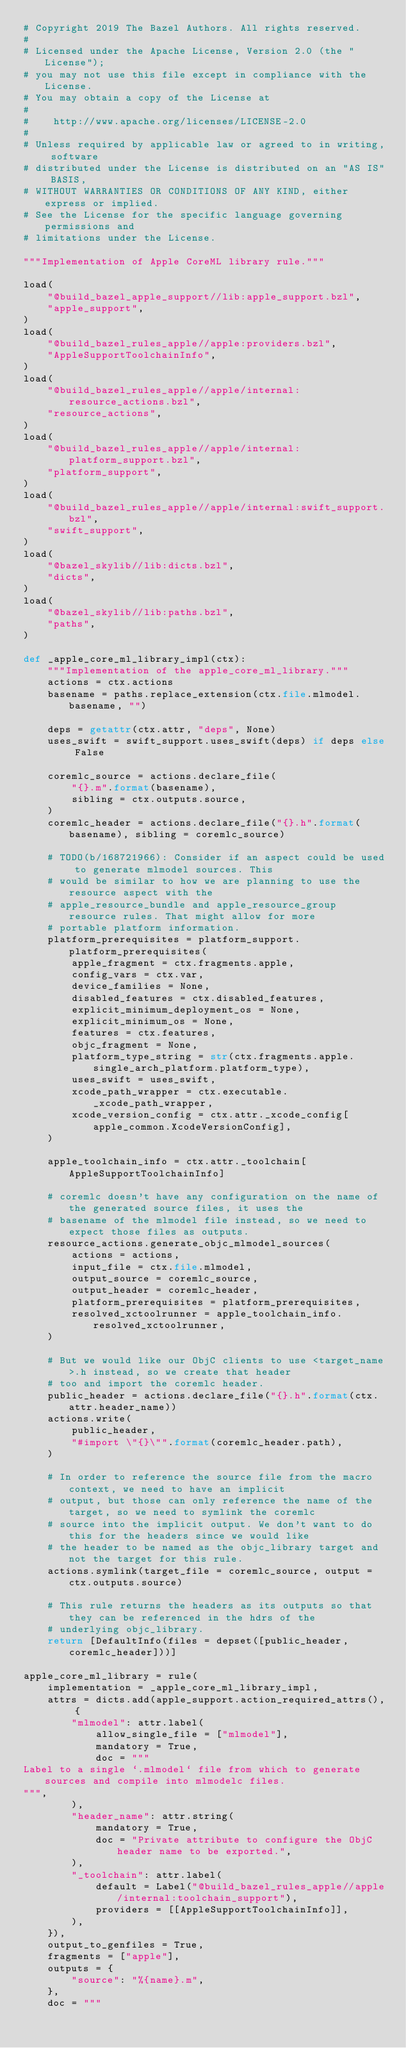Convert code to text. <code><loc_0><loc_0><loc_500><loc_500><_Python_># Copyright 2019 The Bazel Authors. All rights reserved.
#
# Licensed under the Apache License, Version 2.0 (the "License");
# you may not use this file except in compliance with the License.
# You may obtain a copy of the License at
#
#    http://www.apache.org/licenses/LICENSE-2.0
#
# Unless required by applicable law or agreed to in writing, software
# distributed under the License is distributed on an "AS IS" BASIS,
# WITHOUT WARRANTIES OR CONDITIONS OF ANY KIND, either express or implied.
# See the License for the specific language governing permissions and
# limitations under the License.

"""Implementation of Apple CoreML library rule."""

load(
    "@build_bazel_apple_support//lib:apple_support.bzl",
    "apple_support",
)
load(
    "@build_bazel_rules_apple//apple:providers.bzl",
    "AppleSupportToolchainInfo",
)
load(
    "@build_bazel_rules_apple//apple/internal:resource_actions.bzl",
    "resource_actions",
)
load(
    "@build_bazel_rules_apple//apple/internal:platform_support.bzl",
    "platform_support",
)
load(
    "@build_bazel_rules_apple//apple/internal:swift_support.bzl",
    "swift_support",
)
load(
    "@bazel_skylib//lib:dicts.bzl",
    "dicts",
)
load(
    "@bazel_skylib//lib:paths.bzl",
    "paths",
)

def _apple_core_ml_library_impl(ctx):
    """Implementation of the apple_core_ml_library."""
    actions = ctx.actions
    basename = paths.replace_extension(ctx.file.mlmodel.basename, "")

    deps = getattr(ctx.attr, "deps", None)
    uses_swift = swift_support.uses_swift(deps) if deps else False

    coremlc_source = actions.declare_file(
        "{}.m".format(basename),
        sibling = ctx.outputs.source,
    )
    coremlc_header = actions.declare_file("{}.h".format(basename), sibling = coremlc_source)

    # TODO(b/168721966): Consider if an aspect could be used to generate mlmodel sources. This
    # would be similar to how we are planning to use the resource aspect with the
    # apple_resource_bundle and apple_resource_group resource rules. That might allow for more
    # portable platform information.
    platform_prerequisites = platform_support.platform_prerequisites(
        apple_fragment = ctx.fragments.apple,
        config_vars = ctx.var,
        device_families = None,
        disabled_features = ctx.disabled_features,
        explicit_minimum_deployment_os = None,
        explicit_minimum_os = None,
        features = ctx.features,
        objc_fragment = None,
        platform_type_string = str(ctx.fragments.apple.single_arch_platform.platform_type),
        uses_swift = uses_swift,
        xcode_path_wrapper = ctx.executable._xcode_path_wrapper,
        xcode_version_config = ctx.attr._xcode_config[apple_common.XcodeVersionConfig],
    )

    apple_toolchain_info = ctx.attr._toolchain[AppleSupportToolchainInfo]

    # coremlc doesn't have any configuration on the name of the generated source files, it uses the
    # basename of the mlmodel file instead, so we need to expect those files as outputs.
    resource_actions.generate_objc_mlmodel_sources(
        actions = actions,
        input_file = ctx.file.mlmodel,
        output_source = coremlc_source,
        output_header = coremlc_header,
        platform_prerequisites = platform_prerequisites,
        resolved_xctoolrunner = apple_toolchain_info.resolved_xctoolrunner,
    )

    # But we would like our ObjC clients to use <target_name>.h instead, so we create that header
    # too and import the coremlc header.
    public_header = actions.declare_file("{}.h".format(ctx.attr.header_name))
    actions.write(
        public_header,
        "#import \"{}\"".format(coremlc_header.path),
    )

    # In order to reference the source file from the macro context, we need to have an implicit
    # output, but those can only reference the name of the target, so we need to symlink the coremlc
    # source into the implicit output. We don't want to do this for the headers since we would like
    # the header to be named as the objc_library target and not the target for this rule.
    actions.symlink(target_file = coremlc_source, output = ctx.outputs.source)

    # This rule returns the headers as its outputs so that they can be referenced in the hdrs of the
    # underlying objc_library.
    return [DefaultInfo(files = depset([public_header, coremlc_header]))]

apple_core_ml_library = rule(
    implementation = _apple_core_ml_library_impl,
    attrs = dicts.add(apple_support.action_required_attrs(), {
        "mlmodel": attr.label(
            allow_single_file = ["mlmodel"],
            mandatory = True,
            doc = """
Label to a single `.mlmodel` file from which to generate sources and compile into mlmodelc files.
""",
        ),
        "header_name": attr.string(
            mandatory = True,
            doc = "Private attribute to configure the ObjC header name to be exported.",
        ),
        "_toolchain": attr.label(
            default = Label("@build_bazel_rules_apple//apple/internal:toolchain_support"),
            providers = [[AppleSupportToolchainInfo]],
        ),
    }),
    output_to_genfiles = True,
    fragments = ["apple"],
    outputs = {
        "source": "%{name}.m",
    },
    doc = """</code> 